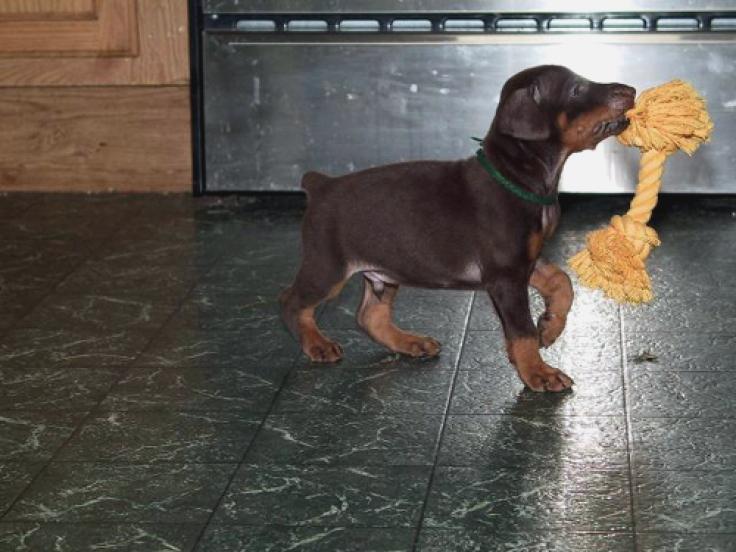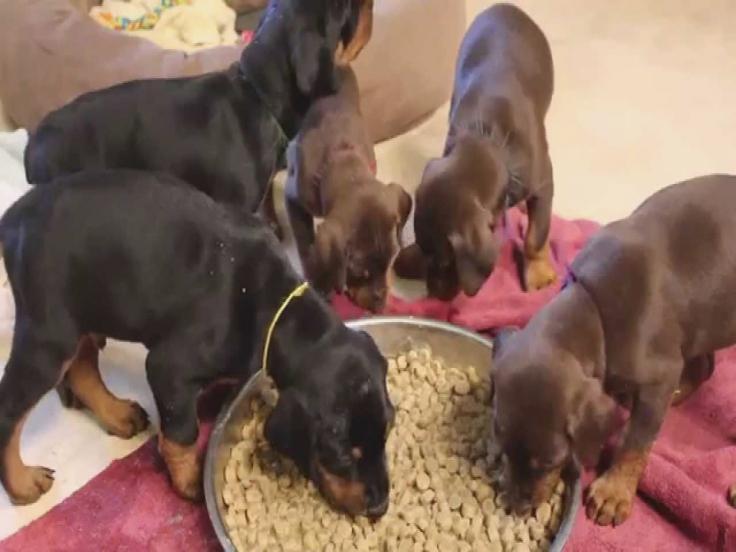The first image is the image on the left, the second image is the image on the right. Evaluate the accuracy of this statement regarding the images: "The right image contains at least three dogs.". Is it true? Answer yes or no. Yes. The first image is the image on the left, the second image is the image on the right. Given the left and right images, does the statement "One dog is laying in the grass." hold true? Answer yes or no. No. 